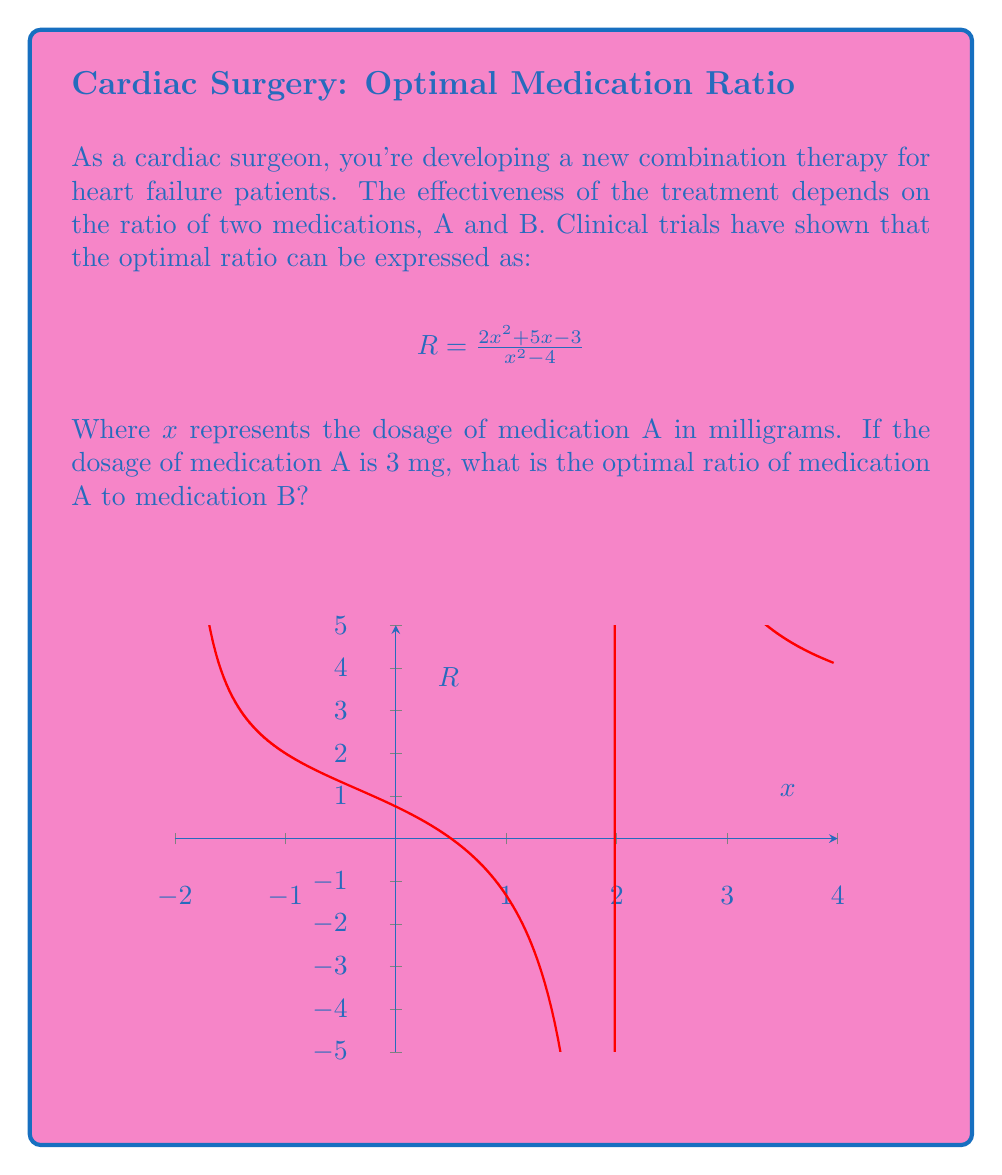What is the answer to this math problem? Let's solve this step-by-step:

1) We're given the ratio formula:
   $$R = \frac{2x^2 + 5x - 3}{x^2 - 4}$$

2) We need to find R when x = 3 mg. Let's substitute x = 3 into the equation:
   $$R = \frac{2(3)^2 + 5(3) - 3}{(3)^2 - 4}$$

3) Simplify the numerator:
   $$R = \frac{2(9) + 15 - 3}{9 - 4}$$
   $$R = \frac{18 + 15 - 3}{5}$$
   $$R = \frac{30}{5}$$

4) Simplify the fraction:
   $$R = 6$$

5) Interpret the result: This means that for every 1 part of medication B, we need 6 parts of medication A.

6) Express as a ratio of A:B = 6:1
Answer: 6:1 